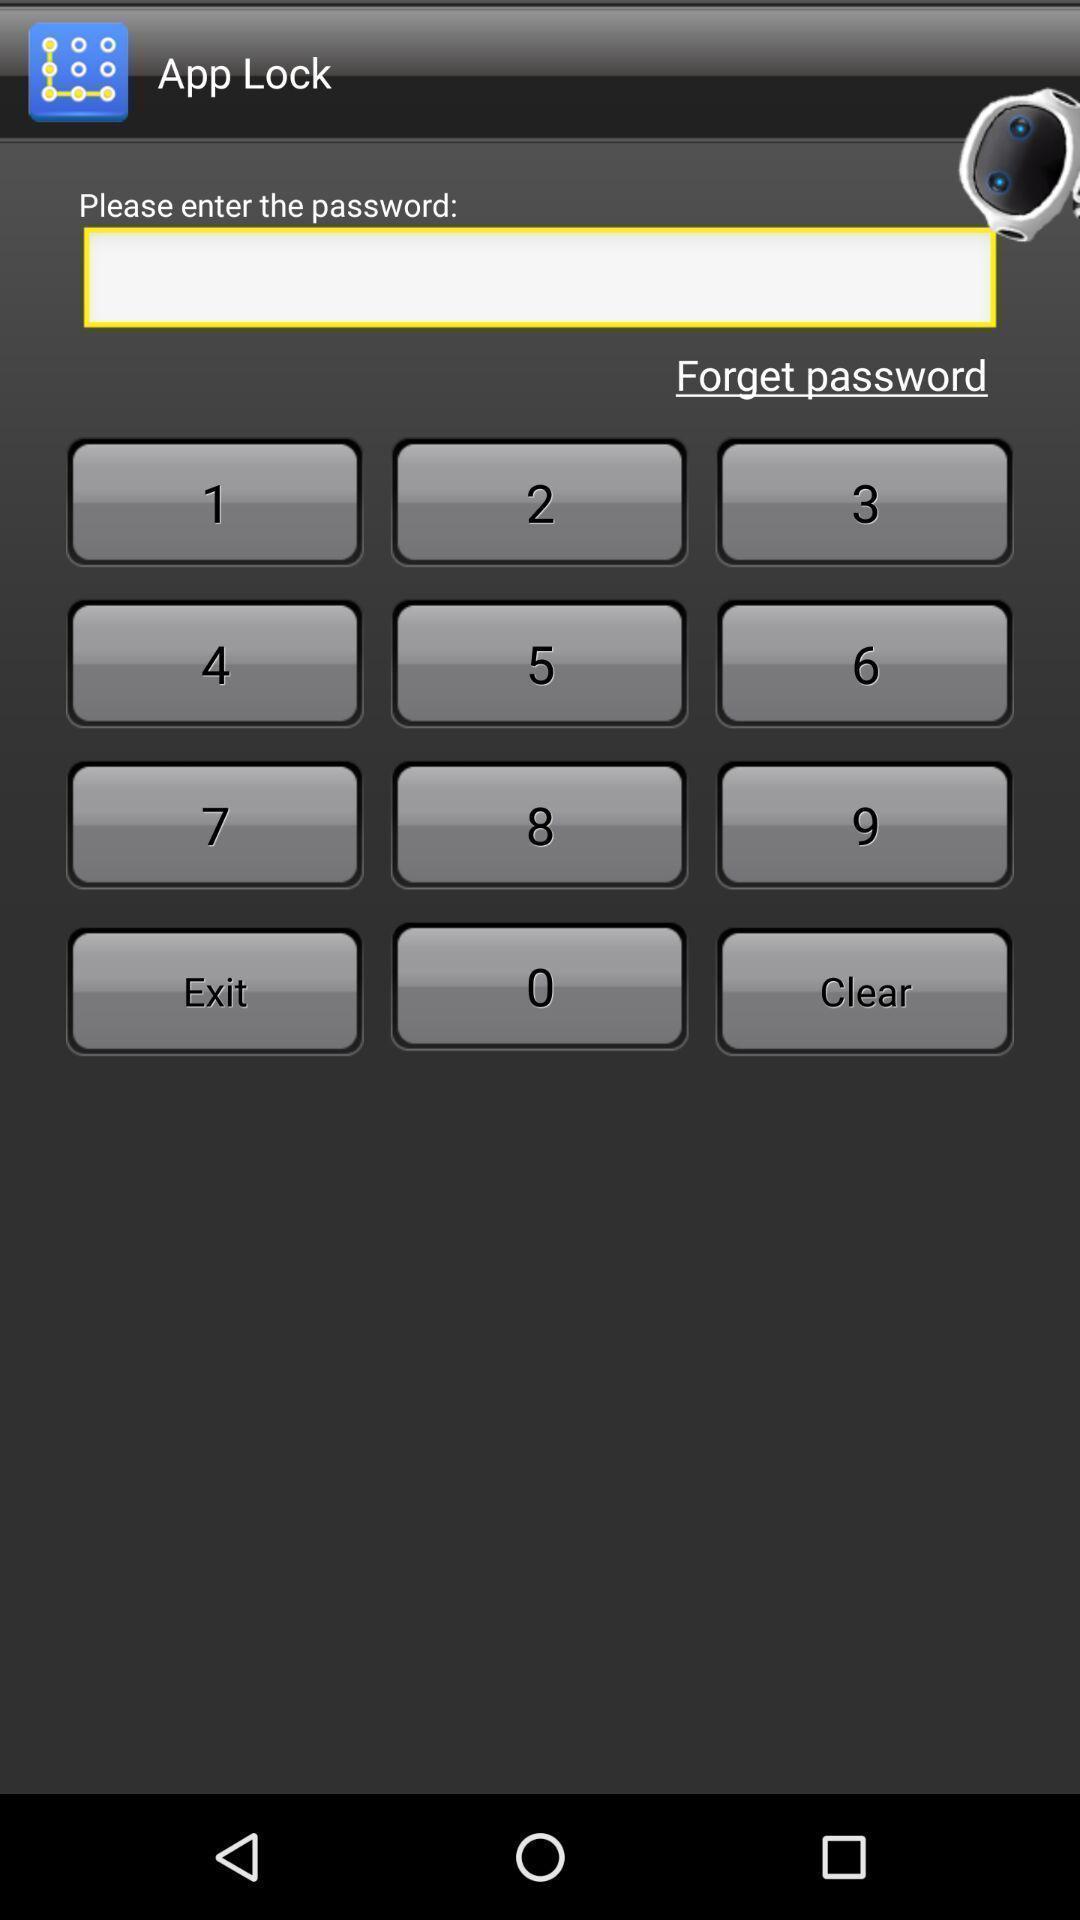Provide a textual representation of this image. Page showing the keypad to enter password. 